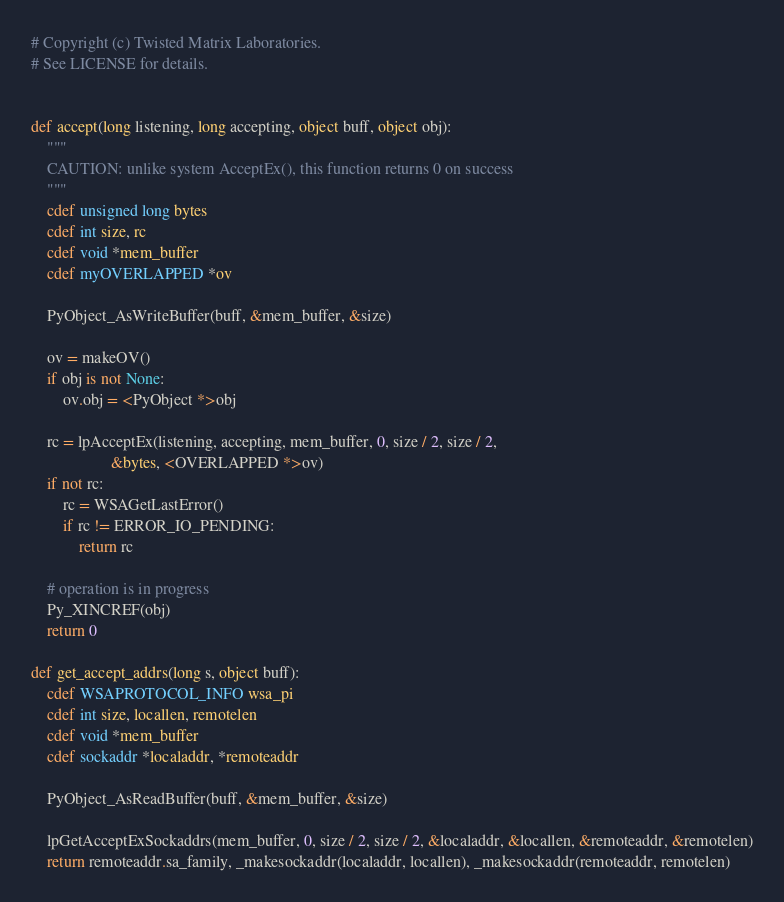<code> <loc_0><loc_0><loc_500><loc_500><_Cython_># Copyright (c) Twisted Matrix Laboratories.
# See LICENSE for details.


def accept(long listening, long accepting, object buff, object obj):
    """
    CAUTION: unlike system AcceptEx(), this function returns 0 on success
    """
    cdef unsigned long bytes
    cdef int size, rc
    cdef void *mem_buffer
    cdef myOVERLAPPED *ov

    PyObject_AsWriteBuffer(buff, &mem_buffer, &size)

    ov = makeOV()
    if obj is not None:
        ov.obj = <PyObject *>obj

    rc = lpAcceptEx(listening, accepting, mem_buffer, 0, size / 2, size / 2,
                    &bytes, <OVERLAPPED *>ov)
    if not rc:
        rc = WSAGetLastError()
        if rc != ERROR_IO_PENDING:
            return rc

    # operation is in progress
    Py_XINCREF(obj)
    return 0

def get_accept_addrs(long s, object buff):
    cdef WSAPROTOCOL_INFO wsa_pi
    cdef int size, locallen, remotelen
    cdef void *mem_buffer
    cdef sockaddr *localaddr, *remoteaddr

    PyObject_AsReadBuffer(buff, &mem_buffer, &size)

    lpGetAcceptExSockaddrs(mem_buffer, 0, size / 2, size / 2, &localaddr, &locallen, &remoteaddr, &remotelen)
    return remoteaddr.sa_family, _makesockaddr(localaddr, locallen), _makesockaddr(remoteaddr, remotelen)

</code> 